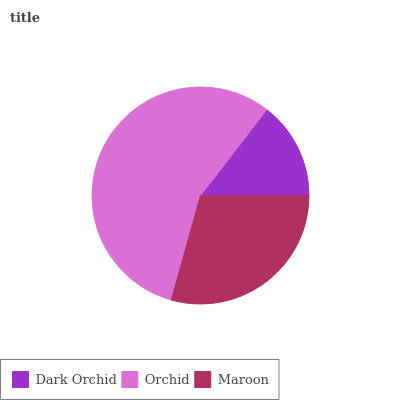Is Dark Orchid the minimum?
Answer yes or no. Yes. Is Orchid the maximum?
Answer yes or no. Yes. Is Maroon the minimum?
Answer yes or no. No. Is Maroon the maximum?
Answer yes or no. No. Is Orchid greater than Maroon?
Answer yes or no. Yes. Is Maroon less than Orchid?
Answer yes or no. Yes. Is Maroon greater than Orchid?
Answer yes or no. No. Is Orchid less than Maroon?
Answer yes or no. No. Is Maroon the high median?
Answer yes or no. Yes. Is Maroon the low median?
Answer yes or no. Yes. Is Orchid the high median?
Answer yes or no. No. Is Dark Orchid the low median?
Answer yes or no. No. 